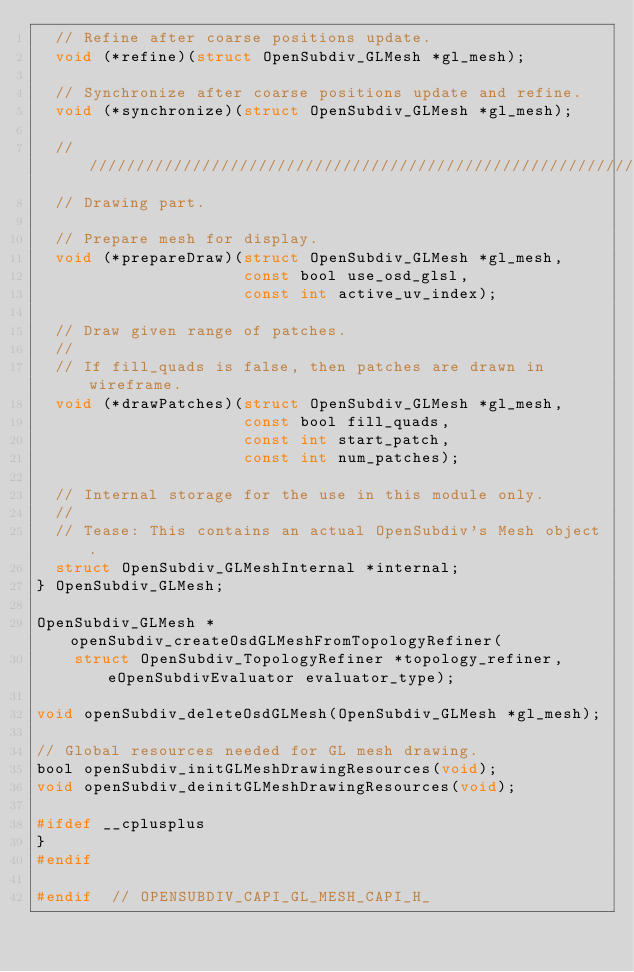Convert code to text. <code><loc_0><loc_0><loc_500><loc_500><_C_>  // Refine after coarse positions update.
  void (*refine)(struct OpenSubdiv_GLMesh *gl_mesh);

  // Synchronize after coarse positions update and refine.
  void (*synchronize)(struct OpenSubdiv_GLMesh *gl_mesh);

  //////////////////////////////////////////////////////////////////////////////
  // Drawing part.

  // Prepare mesh for display.
  void (*prepareDraw)(struct OpenSubdiv_GLMesh *gl_mesh,
                      const bool use_osd_glsl,
                      const int active_uv_index);

  // Draw given range of patches.
  //
  // If fill_quads is false, then patches are drawn in wireframe.
  void (*drawPatches)(struct OpenSubdiv_GLMesh *gl_mesh,
                      const bool fill_quads,
                      const int start_patch,
                      const int num_patches);

  // Internal storage for the use in this module only.
  //
  // Tease: This contains an actual OpenSubdiv's Mesh object.
  struct OpenSubdiv_GLMeshInternal *internal;
} OpenSubdiv_GLMesh;

OpenSubdiv_GLMesh *openSubdiv_createOsdGLMeshFromTopologyRefiner(
    struct OpenSubdiv_TopologyRefiner *topology_refiner, eOpenSubdivEvaluator evaluator_type);

void openSubdiv_deleteOsdGLMesh(OpenSubdiv_GLMesh *gl_mesh);

// Global resources needed for GL mesh drawing.
bool openSubdiv_initGLMeshDrawingResources(void);
void openSubdiv_deinitGLMeshDrawingResources(void);

#ifdef __cplusplus
}
#endif

#endif  // OPENSUBDIV_CAPI_GL_MESH_CAPI_H_
</code> 